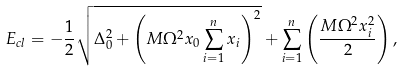Convert formula to latex. <formula><loc_0><loc_0><loc_500><loc_500>E _ { c l } = - \frac { 1 } { 2 } \sqrt { \Delta _ { 0 } ^ { 2 } + \left ( M \Omega ^ { 2 } x _ { 0 } \sum _ { i = 1 } ^ { n } x _ { i } \right ) ^ { 2 } } + \sum _ { i = 1 } ^ { n } \left ( \frac { M \Omega ^ { 2 } x _ { i } ^ { 2 } } { 2 } \right ) ,</formula> 